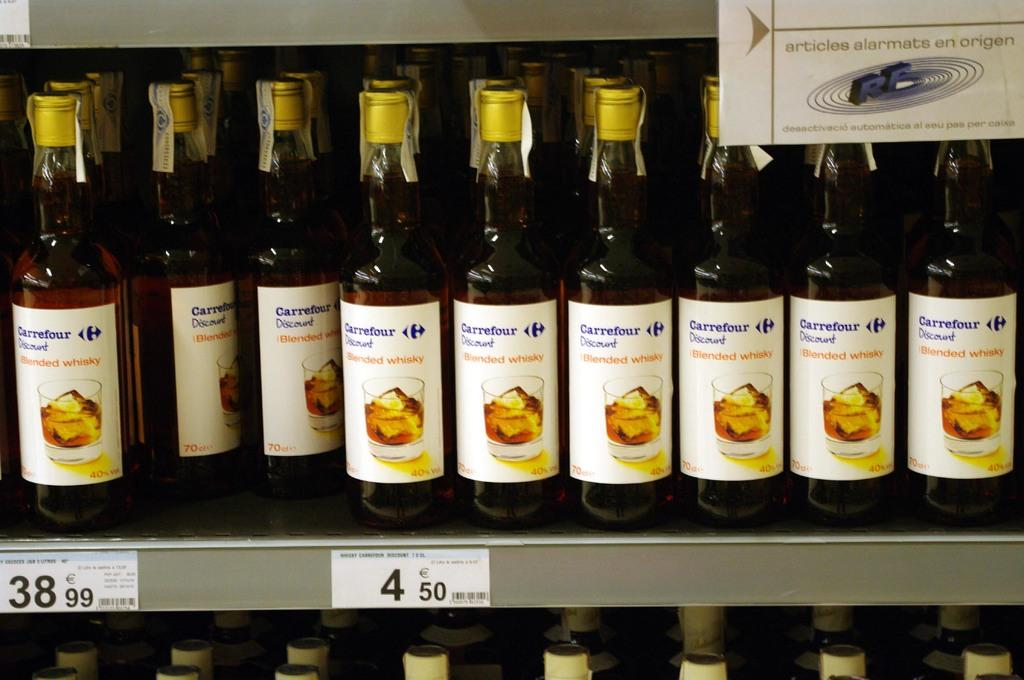<image>
Present a compact description of the photo's key features. Several bottles of blended whiskey are on a store shelf. 